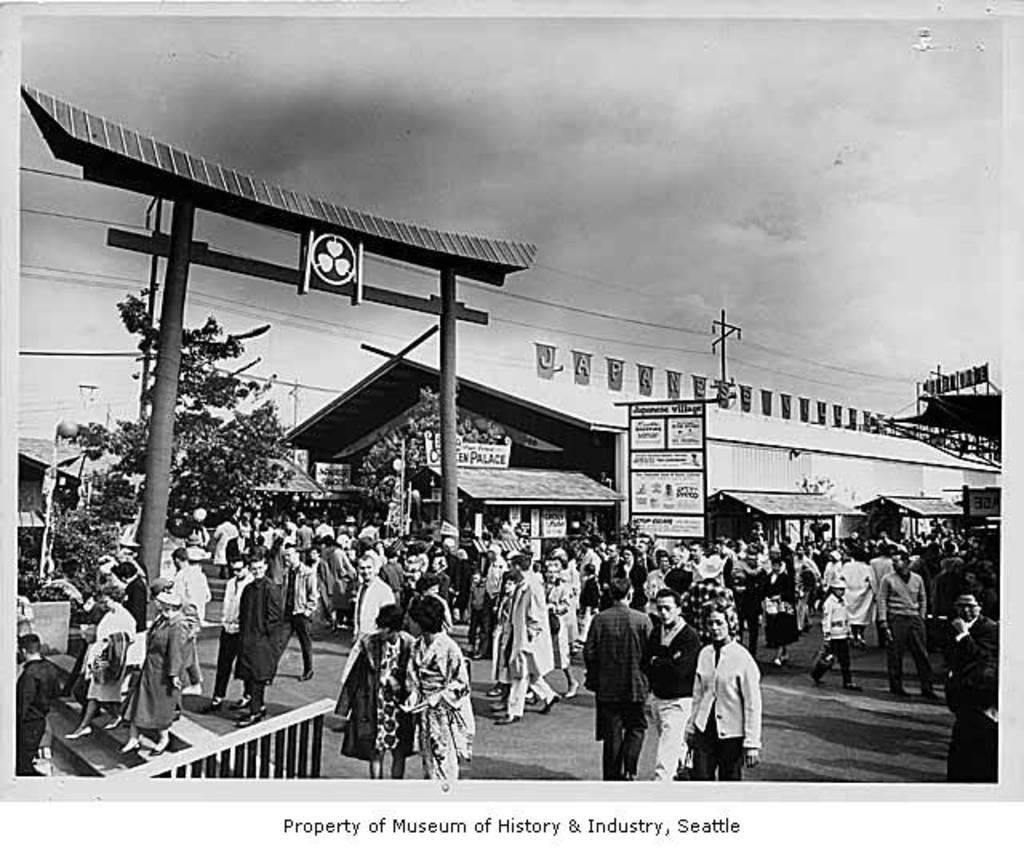Could you give a brief overview of what you see in this image? This black and white picture is clicked on the road. There are many people walking on the road. To the left there are steps. Beside the steps there is a railing. In the background there are houses and trees. To the left there is an arch on the road. Behind the people there are boards to the pole. At the top there is the sky. Below the image there is the text. 